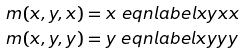Convert formula to latex. <formula><loc_0><loc_0><loc_500><loc_500>m ( x , y , x ) & = x \ e q n l a b e l { x y x x } \\ m ( x , y , y ) & = y \ e q n l a b e l { x y y y }</formula> 